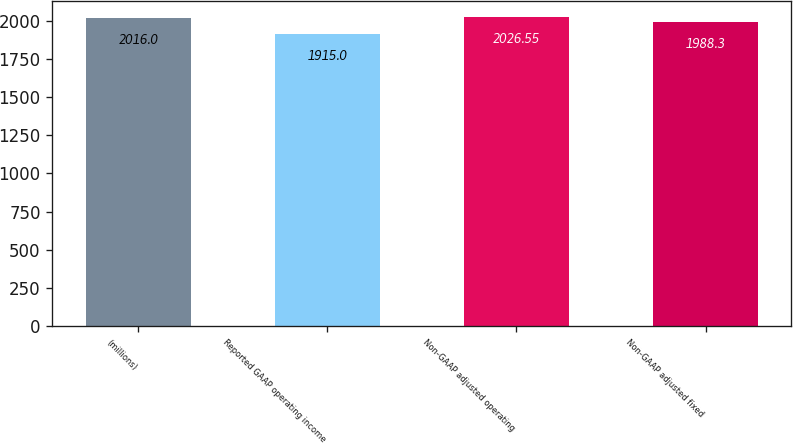<chart> <loc_0><loc_0><loc_500><loc_500><bar_chart><fcel>(millions)<fcel>Reported GAAP operating income<fcel>Non-GAAP adjusted operating<fcel>Non-GAAP adjusted fixed<nl><fcel>2016<fcel>1915<fcel>2026.55<fcel>1988.3<nl></chart> 